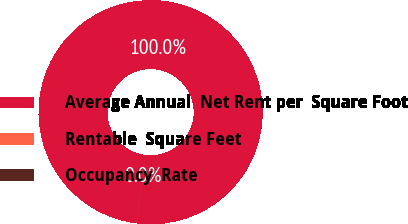Convert chart to OTSL. <chart><loc_0><loc_0><loc_500><loc_500><pie_chart><fcel>Average Annual  Net Rent per  Square Foot<fcel>Rentable  Square Feet<fcel>Occupancy  Rate<nl><fcel>99.97%<fcel>0.02%<fcel>0.01%<nl></chart> 